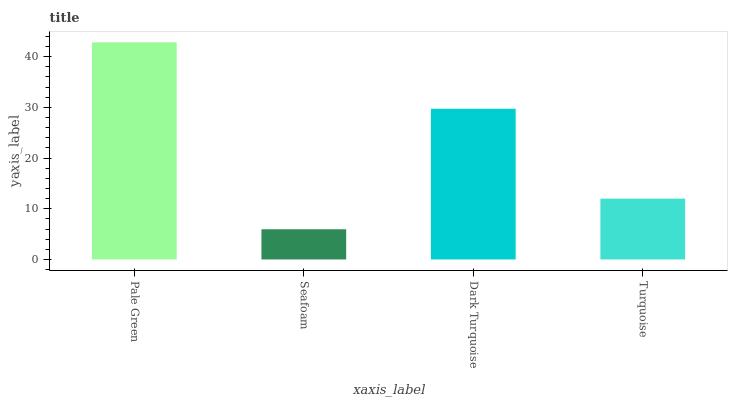Is Seafoam the minimum?
Answer yes or no. Yes. Is Pale Green the maximum?
Answer yes or no. Yes. Is Dark Turquoise the minimum?
Answer yes or no. No. Is Dark Turquoise the maximum?
Answer yes or no. No. Is Dark Turquoise greater than Seafoam?
Answer yes or no. Yes. Is Seafoam less than Dark Turquoise?
Answer yes or no. Yes. Is Seafoam greater than Dark Turquoise?
Answer yes or no. No. Is Dark Turquoise less than Seafoam?
Answer yes or no. No. Is Dark Turquoise the high median?
Answer yes or no. Yes. Is Turquoise the low median?
Answer yes or no. Yes. Is Turquoise the high median?
Answer yes or no. No. Is Dark Turquoise the low median?
Answer yes or no. No. 